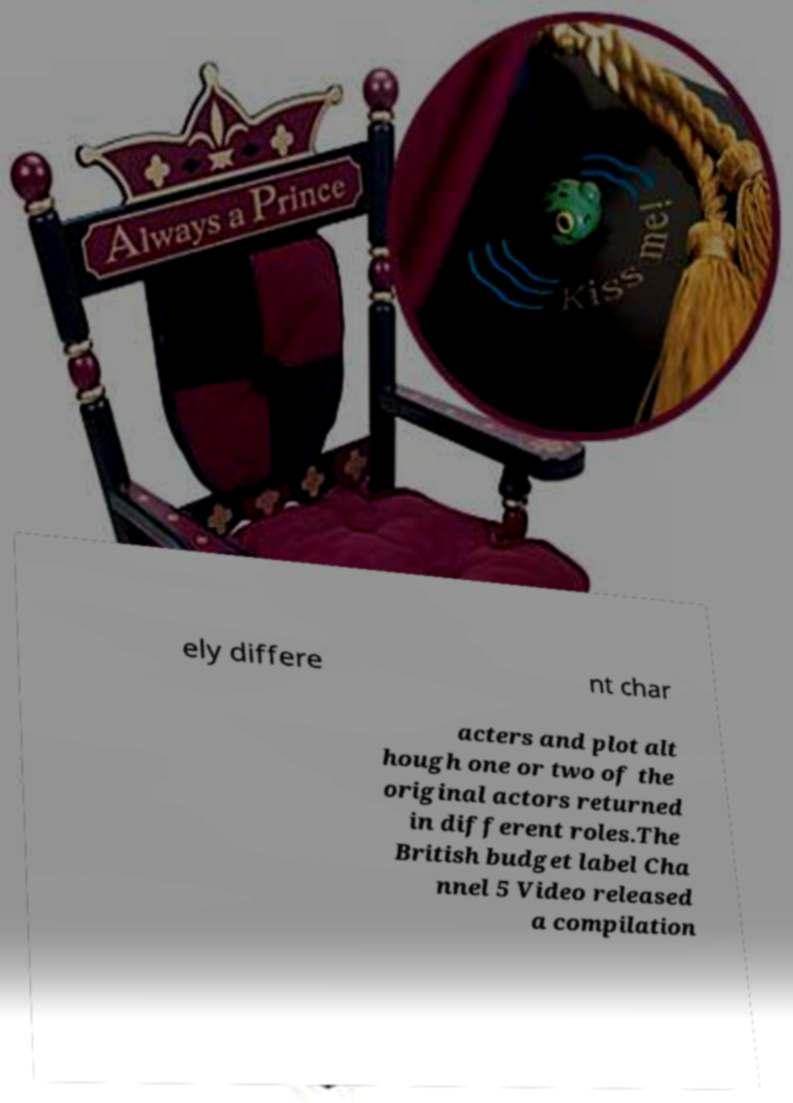Could you extract and type out the text from this image? ely differe nt char acters and plot alt hough one or two of the original actors returned in different roles.The British budget label Cha nnel 5 Video released a compilation 